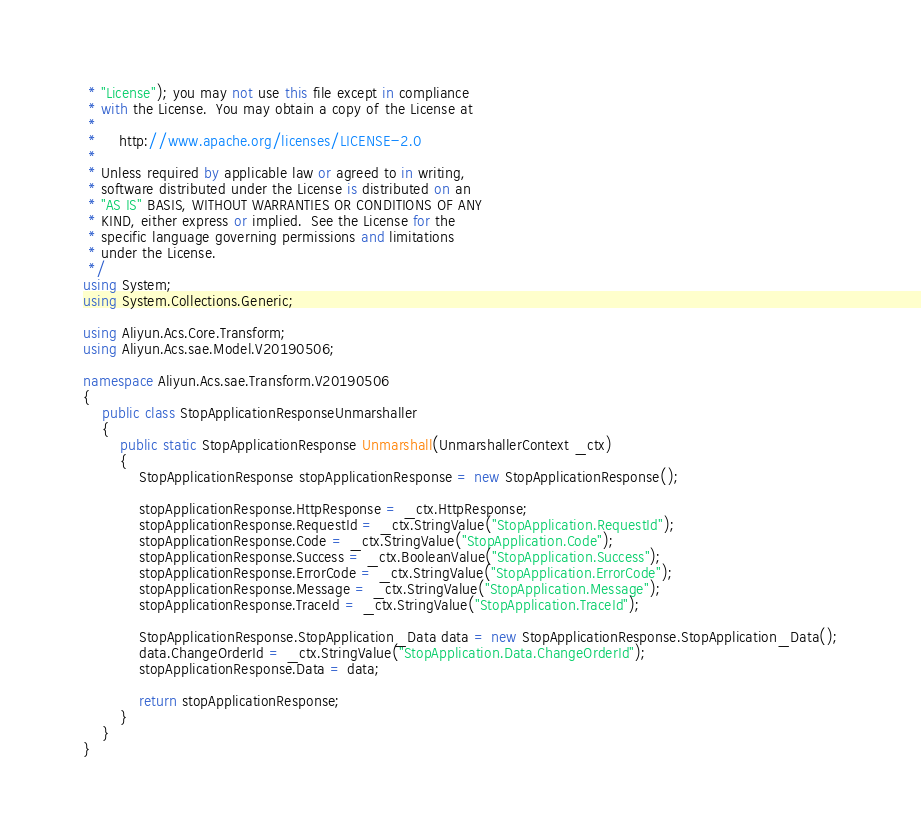<code> <loc_0><loc_0><loc_500><loc_500><_C#_> * "License"); you may not use this file except in compliance
 * with the License.  You may obtain a copy of the License at
 *
 *     http://www.apache.org/licenses/LICENSE-2.0
 *
 * Unless required by applicable law or agreed to in writing,
 * software distributed under the License is distributed on an
 * "AS IS" BASIS, WITHOUT WARRANTIES OR CONDITIONS OF ANY
 * KIND, either express or implied.  See the License for the
 * specific language governing permissions and limitations
 * under the License.
 */
using System;
using System.Collections.Generic;

using Aliyun.Acs.Core.Transform;
using Aliyun.Acs.sae.Model.V20190506;

namespace Aliyun.Acs.sae.Transform.V20190506
{
    public class StopApplicationResponseUnmarshaller
    {
        public static StopApplicationResponse Unmarshall(UnmarshallerContext _ctx)
        {
			StopApplicationResponse stopApplicationResponse = new StopApplicationResponse();

			stopApplicationResponse.HttpResponse = _ctx.HttpResponse;
			stopApplicationResponse.RequestId = _ctx.StringValue("StopApplication.RequestId");
			stopApplicationResponse.Code = _ctx.StringValue("StopApplication.Code");
			stopApplicationResponse.Success = _ctx.BooleanValue("StopApplication.Success");
			stopApplicationResponse.ErrorCode = _ctx.StringValue("StopApplication.ErrorCode");
			stopApplicationResponse.Message = _ctx.StringValue("StopApplication.Message");
			stopApplicationResponse.TraceId = _ctx.StringValue("StopApplication.TraceId");

			StopApplicationResponse.StopApplication_Data data = new StopApplicationResponse.StopApplication_Data();
			data.ChangeOrderId = _ctx.StringValue("StopApplication.Data.ChangeOrderId");
			stopApplicationResponse.Data = data;
        
			return stopApplicationResponse;
        }
    }
}
</code> 